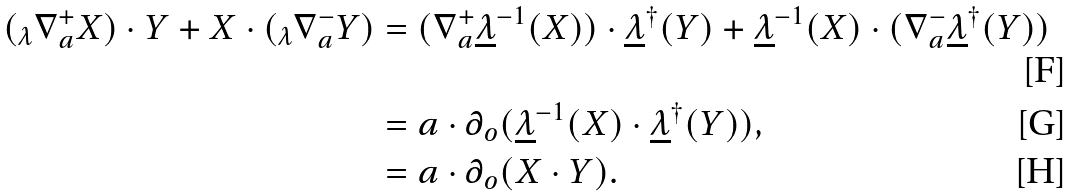Convert formula to latex. <formula><loc_0><loc_0><loc_500><loc_500>( _ { \lambda } \nabla _ { a } ^ { + } X ) \cdot Y + X \cdot ( _ { \lambda } \nabla _ { a } ^ { - } Y ) & = ( \nabla _ { a } ^ { + } \underline { \lambda } ^ { - 1 } ( X ) ) \cdot \underline { \lambda } ^ { \dagger } ( Y ) + \underline { \lambda } ^ { - 1 } ( X ) \cdot ( \nabla _ { a } ^ { - } \underline { \lambda } ^ { \dagger } ( Y ) ) \\ & = a \cdot \partial _ { o } ( \underline { \lambda } ^ { - 1 } ( X ) \cdot \underline { \lambda } ^ { \dagger } ( Y ) ) , \\ & = a \cdot \partial _ { o } ( X \cdot Y ) .</formula> 